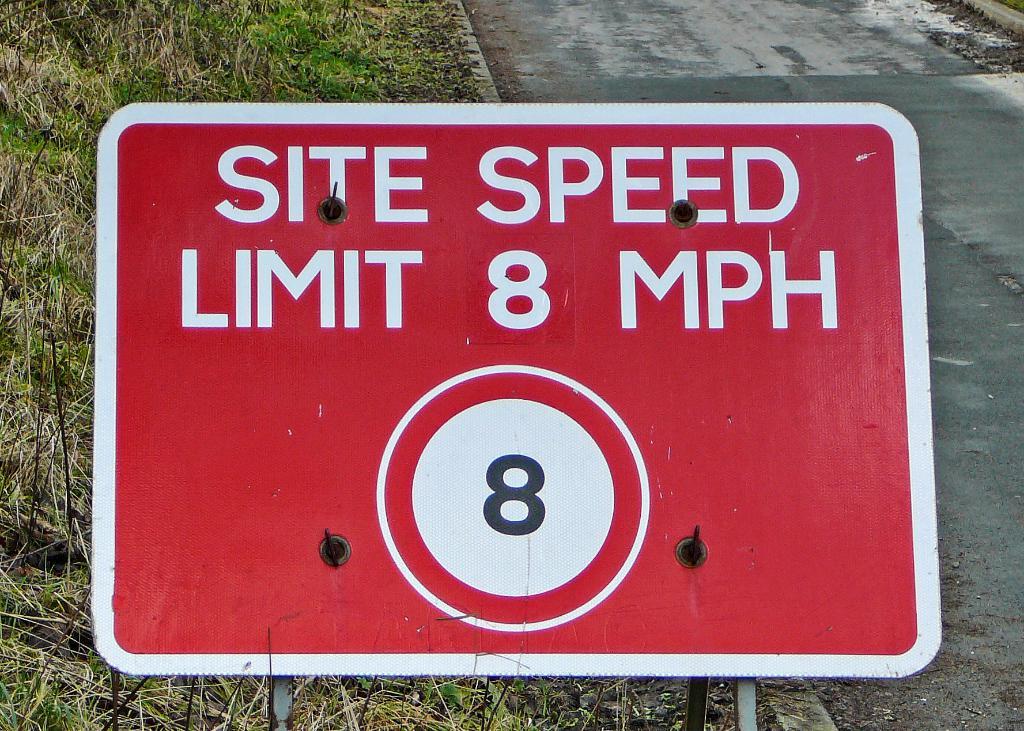What is the speed limit on the site?
Provide a succinct answer. 8 mph. 